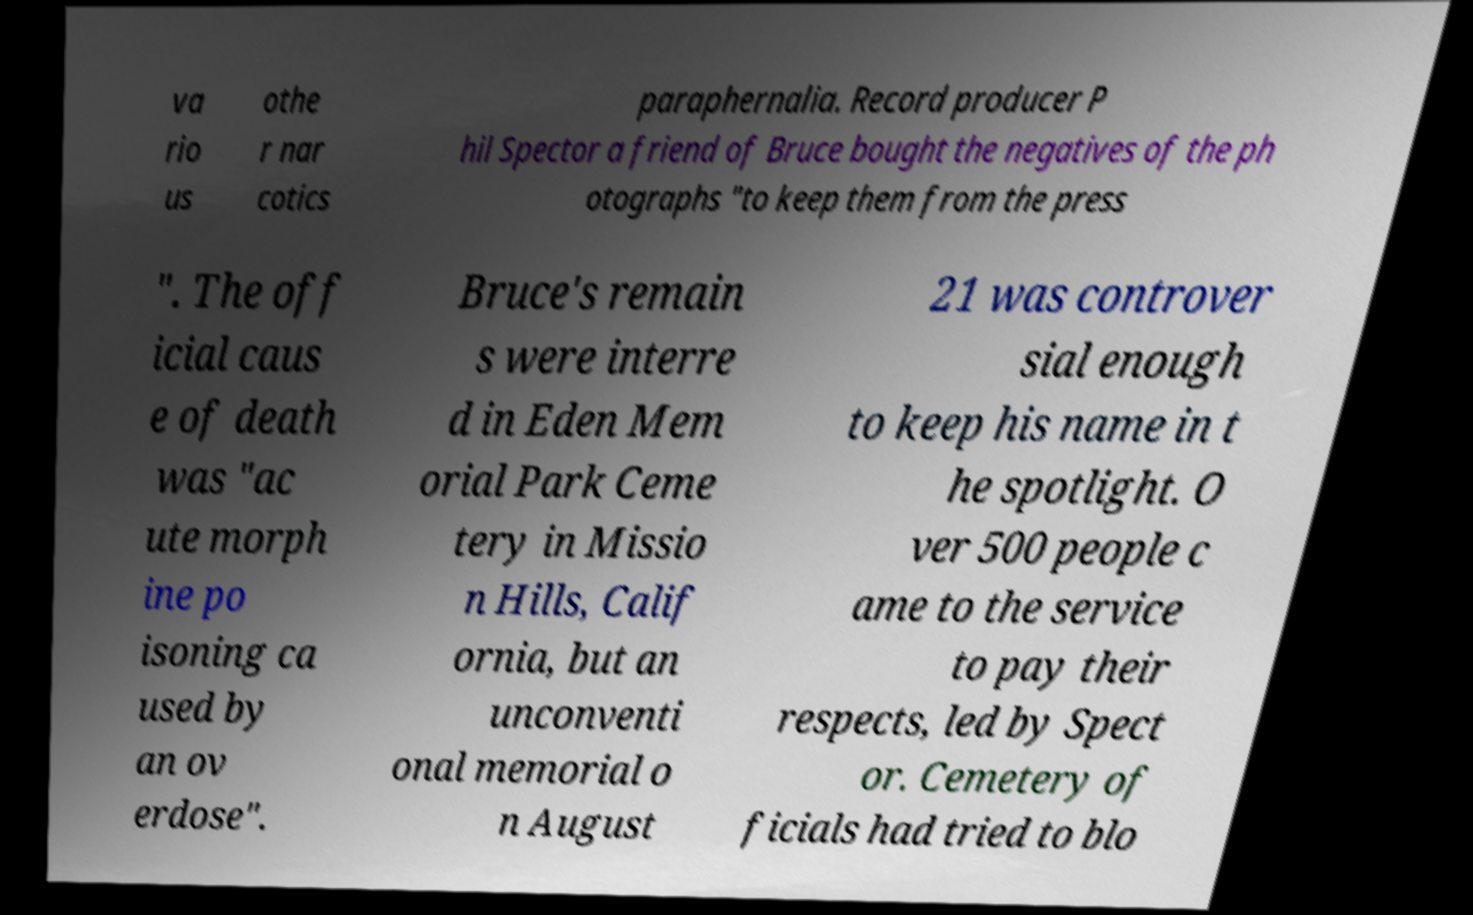Could you assist in decoding the text presented in this image and type it out clearly? va rio us othe r nar cotics paraphernalia. Record producer P hil Spector a friend of Bruce bought the negatives of the ph otographs "to keep them from the press ". The off icial caus e of death was "ac ute morph ine po isoning ca used by an ov erdose". Bruce's remain s were interre d in Eden Mem orial Park Ceme tery in Missio n Hills, Calif ornia, but an unconventi onal memorial o n August 21 was controver sial enough to keep his name in t he spotlight. O ver 500 people c ame to the service to pay their respects, led by Spect or. Cemetery of ficials had tried to blo 